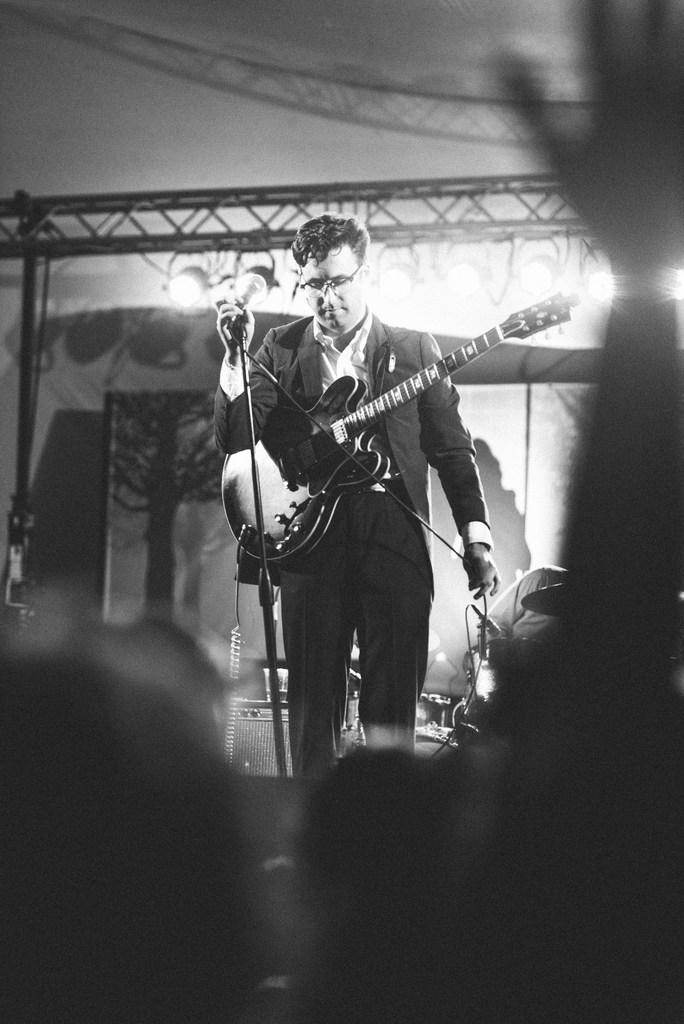What is the man in the foreground of the image holding? The man is holding a microphone and a guitar in the image. What is happening in the background of the image? There is a man playing drums in the background of the image. What type of lighting is present in the image? There are focus lights attached to iron rods in the image. What can be seen in the distance in the image? There is a scenery in the background of the image. What type of flag is being waved in the image? There is no flag present in the image. What holiday is being celebrated in the image? There is no indication of a holiday being celebrated in the image. 